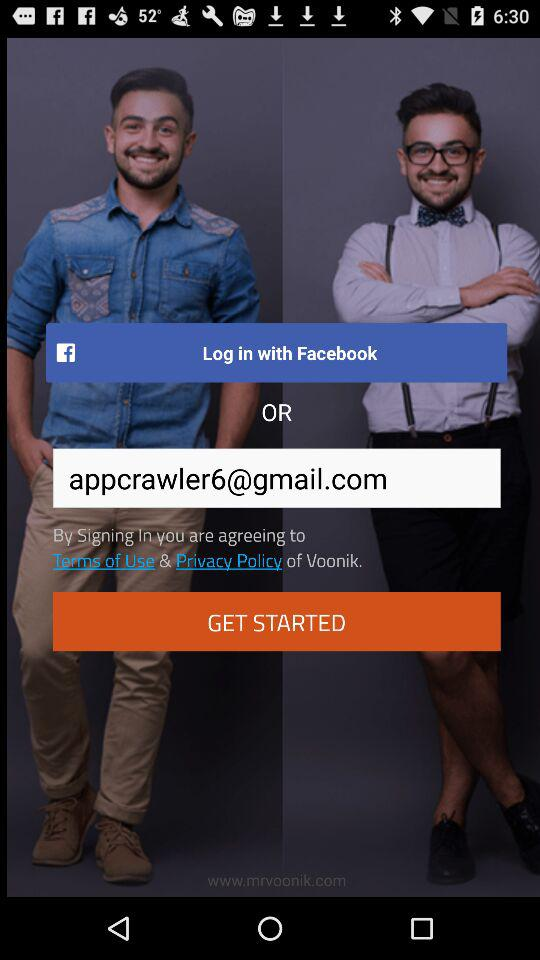What is the email address? The email address is appcrawler6@gmail.com. 